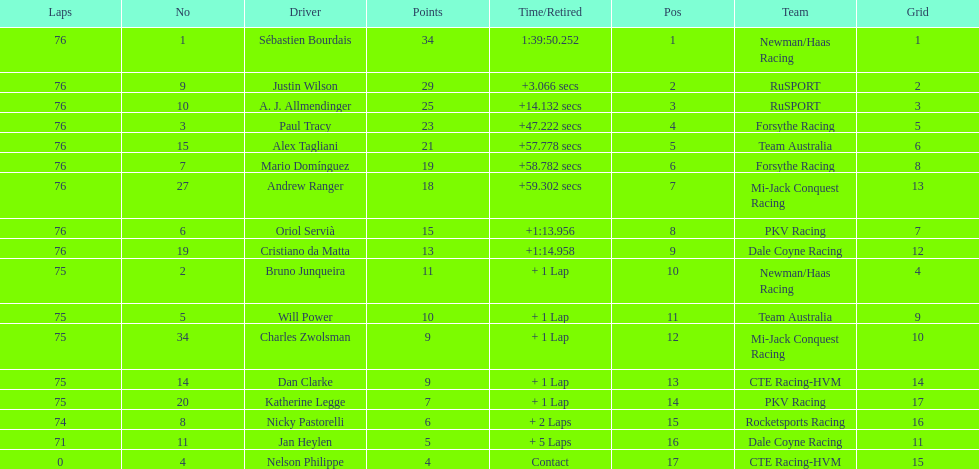How many drivers were competing for brazil? 2. 